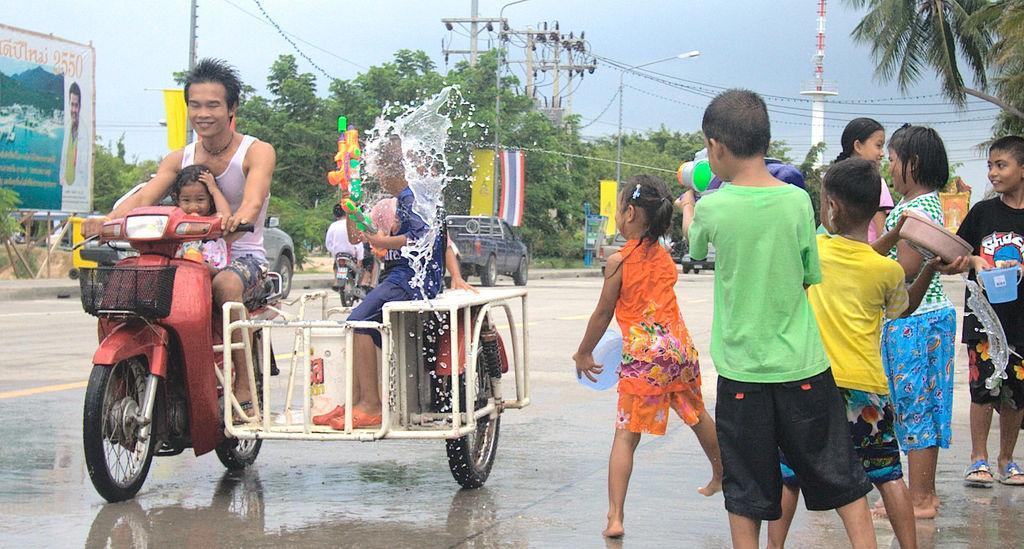Describe this image in one or two sentences. In this picture we can observe a person driving a bike. There are some children on this bike. We can observe maroon color bike. On the right side there are some children. We can observe a poster on the left side. In the background there are trees, poles and a sky. 